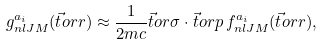Convert formula to latex. <formula><loc_0><loc_0><loc_500><loc_500>g _ { n l J M } ^ { a _ { i } } ( { \vec { t } o r { r } } ) \approx { \frac { 1 } { 2 m c } } { \vec { t } o r { \sigma } } \cdot { \vec { t } o r { p } } \, f _ { n l J M } ^ { a _ { i } } ( { \vec { t } o r { r } } ) ,</formula> 